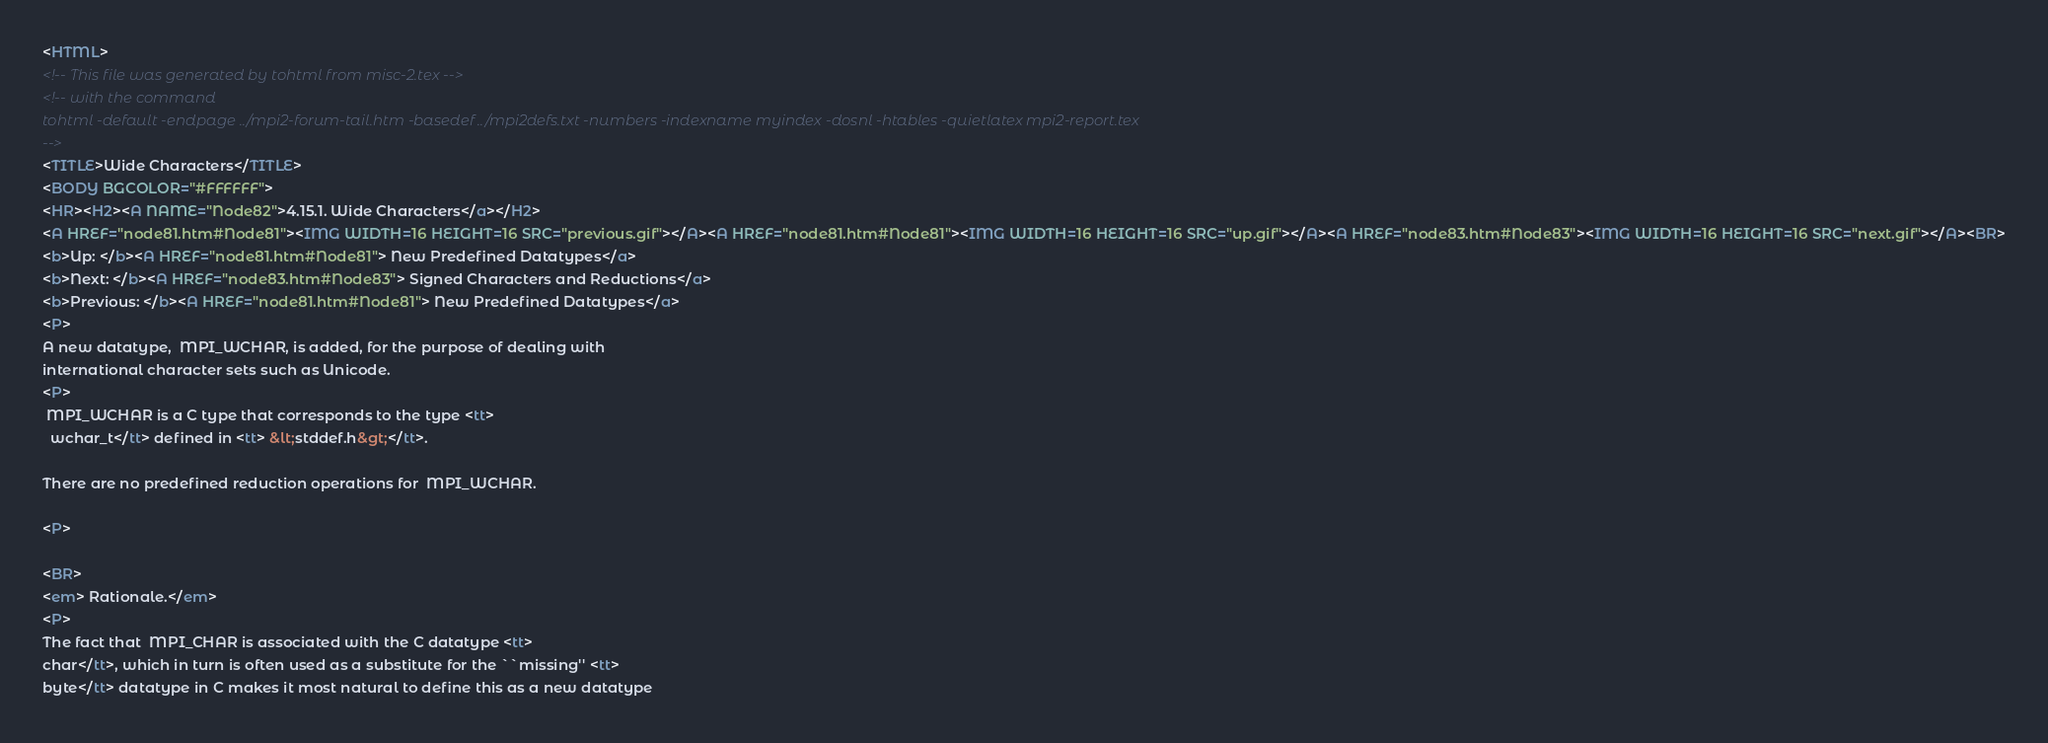Convert code to text. <code><loc_0><loc_0><loc_500><loc_500><_HTML_><HTML>
<!-- This file was generated by tohtml from misc-2.tex -->
<!-- with the command
tohtml -default -endpage ../mpi2-forum-tail.htm -basedef ../mpi2defs.txt -numbers -indexname myindex -dosnl -htables -quietlatex mpi2-report.tex 
-->
<TITLE>Wide Characters</TITLE>
<BODY BGCOLOR="#FFFFFF">
<HR><H2><A NAME="Node82">4.15.1. Wide Characters</a></H2>
<A HREF="node81.htm#Node81"><IMG WIDTH=16 HEIGHT=16 SRC="previous.gif"></A><A HREF="node81.htm#Node81"><IMG WIDTH=16 HEIGHT=16 SRC="up.gif"></A><A HREF="node83.htm#Node83"><IMG WIDTH=16 HEIGHT=16 SRC="next.gif"></A><BR>
<b>Up: </b><A HREF="node81.htm#Node81"> New Predefined Datatypes</a>
<b>Next: </b><A HREF="node83.htm#Node83"> Signed Characters and Reductions</a>
<b>Previous: </b><A HREF="node81.htm#Node81"> New Predefined Datatypes</a>
<P>
A new datatype,  MPI_WCHAR, is added, for the purpose of dealing with  
international character sets such as Unicode.    
<P> 
 MPI_WCHAR is a C type that corresponds to the type <tt>  
  wchar_t</tt> defined in <tt> &lt;stddef.h&gt;</tt>.   
  
There are no predefined reduction operations for  MPI_WCHAR.  
  
<P> 
 
<BR> 
<em> Rationale.</em>  
<P> 
The fact that  MPI_CHAR is associated with the C datatype <tt>  
char</tt>, which in turn is often used as a substitute for the ``missing'' <tt>  
byte</tt> datatype in C makes it most natural to define this as a new datatype  </code> 